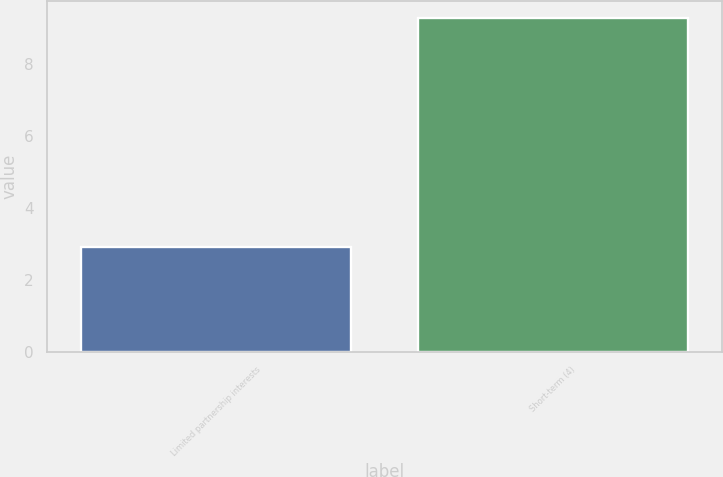<chart> <loc_0><loc_0><loc_500><loc_500><bar_chart><fcel>Limited partnership interests<fcel>Short-term (4)<nl><fcel>2.9<fcel>9.3<nl></chart> 